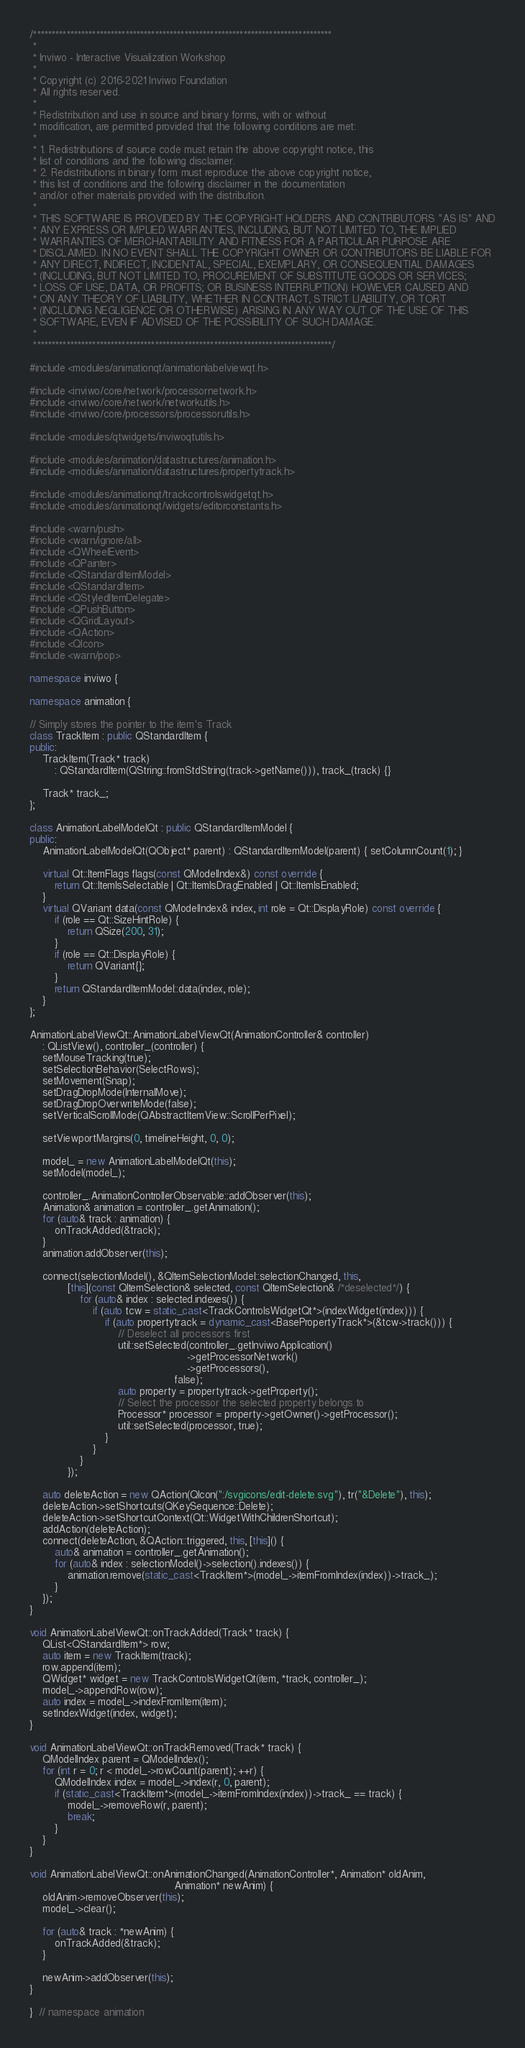<code> <loc_0><loc_0><loc_500><loc_500><_C++_>/*********************************************************************************
 *
 * Inviwo - Interactive Visualization Workshop
 *
 * Copyright (c) 2016-2021 Inviwo Foundation
 * All rights reserved.
 *
 * Redistribution and use in source and binary forms, with or without
 * modification, are permitted provided that the following conditions are met:
 *
 * 1. Redistributions of source code must retain the above copyright notice, this
 * list of conditions and the following disclaimer.
 * 2. Redistributions in binary form must reproduce the above copyright notice,
 * this list of conditions and the following disclaimer in the documentation
 * and/or other materials provided with the distribution.
 *
 * THIS SOFTWARE IS PROVIDED BY THE COPYRIGHT HOLDERS AND CONTRIBUTORS "AS IS" AND
 * ANY EXPRESS OR IMPLIED WARRANTIES, INCLUDING, BUT NOT LIMITED TO, THE IMPLIED
 * WARRANTIES OF MERCHANTABILITY AND FITNESS FOR A PARTICULAR PURPOSE ARE
 * DISCLAIMED. IN NO EVENT SHALL THE COPYRIGHT OWNER OR CONTRIBUTORS BE LIABLE FOR
 * ANY DIRECT, INDIRECT, INCIDENTAL, SPECIAL, EXEMPLARY, OR CONSEQUENTIAL DAMAGES
 * (INCLUDING, BUT NOT LIMITED TO, PROCUREMENT OF SUBSTITUTE GOODS OR SERVICES;
 * LOSS OF USE, DATA, OR PROFITS; OR BUSINESS INTERRUPTION) HOWEVER CAUSED AND
 * ON ANY THEORY OF LIABILITY, WHETHER IN CONTRACT, STRICT LIABILITY, OR TORT
 * (INCLUDING NEGLIGENCE OR OTHERWISE) ARISING IN ANY WAY OUT OF THE USE OF THIS
 * SOFTWARE, EVEN IF ADVISED OF THE POSSIBILITY OF SUCH DAMAGE.
 *
 *********************************************************************************/

#include <modules/animationqt/animationlabelviewqt.h>

#include <inviwo/core/network/processornetwork.h>
#include <inviwo/core/network/networkutils.h>
#include <inviwo/core/processors/processorutils.h>

#include <modules/qtwidgets/inviwoqtutils.h>

#include <modules/animation/datastructures/animation.h>
#include <modules/animation/datastructures/propertytrack.h>

#include <modules/animationqt/trackcontrolswidgetqt.h>
#include <modules/animationqt/widgets/editorconstants.h>

#include <warn/push>
#include <warn/ignore/all>
#include <QWheelEvent>
#include <QPainter>
#include <QStandardItemModel>
#include <QStandardItem>
#include <QStyledItemDelegate>
#include <QPushButton>
#include <QGridLayout>
#include <QAction>
#include <QIcon>
#include <warn/pop>

namespace inviwo {

namespace animation {

// Simply stores the pointer to the item's Track
class TrackItem : public QStandardItem {
public:
    TrackItem(Track* track)
        : QStandardItem(QString::fromStdString(track->getName())), track_(track) {}

    Track* track_;
};

class AnimationLabelModelQt : public QStandardItemModel {
public:
    AnimationLabelModelQt(QObject* parent) : QStandardItemModel(parent) { setColumnCount(1); }

    virtual Qt::ItemFlags flags(const QModelIndex&) const override {
        return Qt::ItemIsSelectable | Qt::ItemIsDragEnabled | Qt::ItemIsEnabled;
    }
    virtual QVariant data(const QModelIndex& index, int role = Qt::DisplayRole) const override {
        if (role == Qt::SizeHintRole) {
            return QSize(200, 31);
        }
        if (role == Qt::DisplayRole) {
            return QVariant{};
        }
        return QStandardItemModel::data(index, role);
    }
};

AnimationLabelViewQt::AnimationLabelViewQt(AnimationController& controller)
    : QListView(), controller_(controller) {
    setMouseTracking(true);
    setSelectionBehavior(SelectRows);
    setMovement(Snap);
    setDragDropMode(InternalMove);
    setDragDropOverwriteMode(false);
    setVerticalScrollMode(QAbstractItemView::ScrollPerPixel);

    setViewportMargins(0, timelineHeight, 0, 0);

    model_ = new AnimationLabelModelQt(this);
    setModel(model_);

    controller_.AnimationControllerObservable::addObserver(this);
    Animation& animation = controller_.getAnimation();
    for (auto& track : animation) {
        onTrackAdded(&track);
    }
    animation.addObserver(this);

    connect(selectionModel(), &QItemSelectionModel::selectionChanged, this,
            [this](const QItemSelection& selected, const QItemSelection& /*deselected*/) {
                for (auto& index : selected.indexes()) {
                    if (auto tcw = static_cast<TrackControlsWidgetQt*>(indexWidget(index))) {
                        if (auto propertytrack = dynamic_cast<BasePropertyTrack*>(&tcw->track())) {
                            // Deselect all processors first
                            util::setSelected(controller_.getInviwoApplication()
                                                  ->getProcessorNetwork()
                                                  ->getProcessors(),
                                              false);
                            auto property = propertytrack->getProperty();
                            // Select the processor the selected property belongs to
                            Processor* processor = property->getOwner()->getProcessor();
                            util::setSelected(processor, true);
                        }
                    }
                }
            });

    auto deleteAction = new QAction(QIcon(":/svgicons/edit-delete.svg"), tr("&Delete"), this);
    deleteAction->setShortcuts(QKeySequence::Delete);
    deleteAction->setShortcutContext(Qt::WidgetWithChildrenShortcut);
    addAction(deleteAction);
    connect(deleteAction, &QAction::triggered, this, [this]() {
        auto& animation = controller_.getAnimation();
        for (auto& index : selectionModel()->selection().indexes()) {
            animation.remove(static_cast<TrackItem*>(model_->itemFromIndex(index))->track_);
        }
    });
}

void AnimationLabelViewQt::onTrackAdded(Track* track) {
    QList<QStandardItem*> row;
    auto item = new TrackItem(track);
    row.append(item);
    QWidget* widget = new TrackControlsWidgetQt(item, *track, controller_);
    model_->appendRow(row);
    auto index = model_->indexFromItem(item);
    setIndexWidget(index, widget);
}

void AnimationLabelViewQt::onTrackRemoved(Track* track) {
    QModelIndex parent = QModelIndex();
    for (int r = 0; r < model_->rowCount(parent); ++r) {
        QModelIndex index = model_->index(r, 0, parent);
        if (static_cast<TrackItem*>(model_->itemFromIndex(index))->track_ == track) {
            model_->removeRow(r, parent);
            break;
        }
    }
}

void AnimationLabelViewQt::onAnimationChanged(AnimationController*, Animation* oldAnim,
                                              Animation* newAnim) {
    oldAnim->removeObserver(this);
    model_->clear();

    for (auto& track : *newAnim) {
        onTrackAdded(&track);
    }

    newAnim->addObserver(this);
}

}  // namespace animation
</code> 